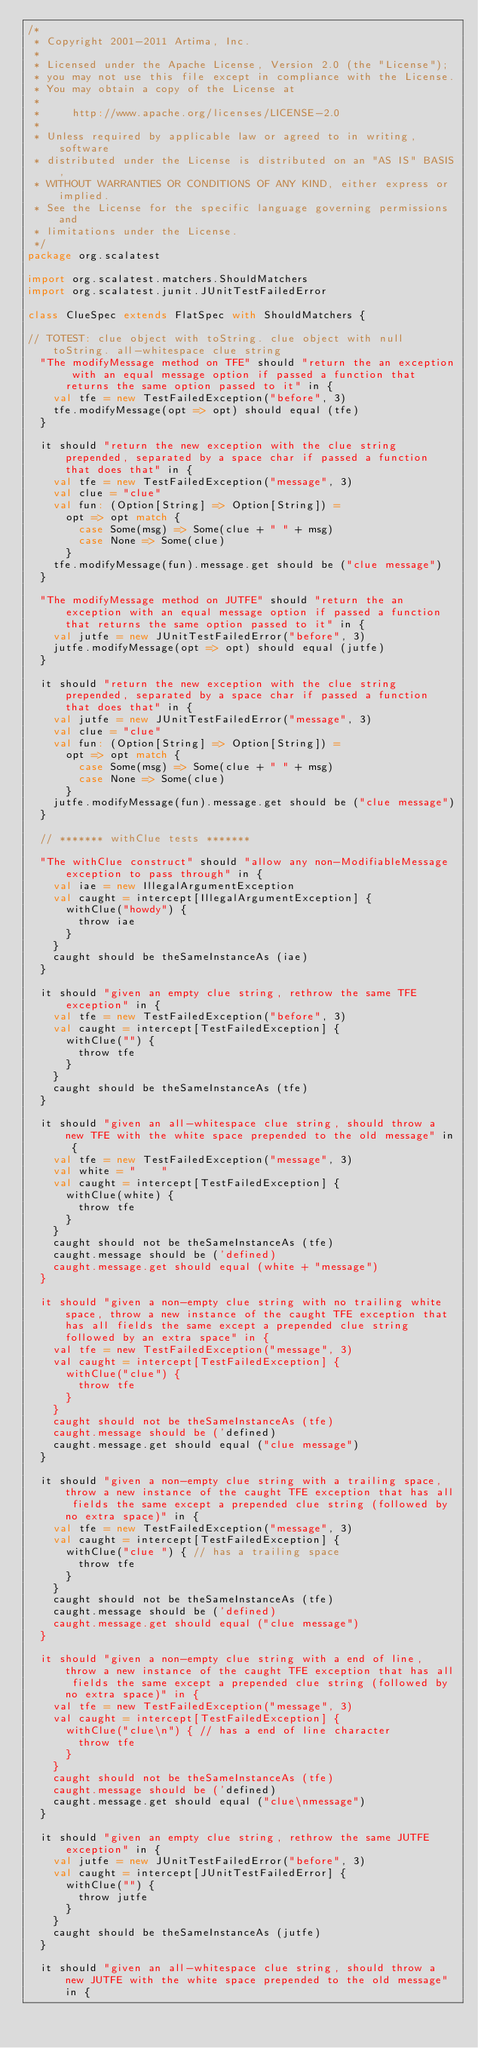<code> <loc_0><loc_0><loc_500><loc_500><_Scala_>/*
 * Copyright 2001-2011 Artima, Inc.
 *
 * Licensed under the Apache License, Version 2.0 (the "License");
 * you may not use this file except in compliance with the License.
 * You may obtain a copy of the License at
 *
 *     http://www.apache.org/licenses/LICENSE-2.0
 *
 * Unless required by applicable law or agreed to in writing, software
 * distributed under the License is distributed on an "AS IS" BASIS,
 * WITHOUT WARRANTIES OR CONDITIONS OF ANY KIND, either express or implied.
 * See the License for the specific language governing permissions and
 * limitations under the License.
 */
package org.scalatest

import org.scalatest.matchers.ShouldMatchers
import org.scalatest.junit.JUnitTestFailedError

class ClueSpec extends FlatSpec with ShouldMatchers {

// TOTEST: clue object with toString. clue object with null toString. all-whitespace clue string
  "The modifyMessage method on TFE" should "return the an exception with an equal message option if passed a function that returns the same option passed to it" in {
    val tfe = new TestFailedException("before", 3)
    tfe.modifyMessage(opt => opt) should equal (tfe)
  }

  it should "return the new exception with the clue string prepended, separated by a space char if passed a function that does that" in {
    val tfe = new TestFailedException("message", 3)
    val clue = "clue"
    val fun: (Option[String] => Option[String]) =
      opt => opt match {
        case Some(msg) => Some(clue + " " + msg)
        case None => Some(clue)
      }
    tfe.modifyMessage(fun).message.get should be ("clue message")
  }

  "The modifyMessage method on JUTFE" should "return the an exception with an equal message option if passed a function that returns the same option passed to it" in {
    val jutfe = new JUnitTestFailedError("before", 3)
    jutfe.modifyMessage(opt => opt) should equal (jutfe)
  }

  it should "return the new exception with the clue string prepended, separated by a space char if passed a function that does that" in {
    val jutfe = new JUnitTestFailedError("message", 3)
    val clue = "clue"
    val fun: (Option[String] => Option[String]) =
      opt => opt match {
        case Some(msg) => Some(clue + " " + msg)
        case None => Some(clue)
      }
    jutfe.modifyMessage(fun).message.get should be ("clue message")
  }

  // ******* withClue tests *******

  "The withClue construct" should "allow any non-ModifiableMessage exception to pass through" in {
    val iae = new IllegalArgumentException
    val caught = intercept[IllegalArgumentException] {
      withClue("howdy") {
        throw iae 
      }
    }
    caught should be theSameInstanceAs (iae)
  }

  it should "given an empty clue string, rethrow the same TFE exception" in {
    val tfe = new TestFailedException("before", 3)
    val caught = intercept[TestFailedException] {
      withClue("") {
        throw tfe 
      }
    }
    caught should be theSameInstanceAs (tfe)
  }

  it should "given an all-whitespace clue string, should throw a new TFE with the white space prepended to the old message" in {
    val tfe = new TestFailedException("message", 3)
    val white = "    "
    val caught = intercept[TestFailedException] {
      withClue(white) {
        throw tfe 
      }
    }
    caught should not be theSameInstanceAs (tfe)
    caught.message should be ('defined)
    caught.message.get should equal (white + "message")
  }

  it should "given a non-empty clue string with no trailing white space, throw a new instance of the caught TFE exception that has all fields the same except a prepended clue string followed by an extra space" in {
    val tfe = new TestFailedException("message", 3)
    val caught = intercept[TestFailedException] {
      withClue("clue") {
        throw tfe 
      }
    }
    caught should not be theSameInstanceAs (tfe)
    caught.message should be ('defined)
    caught.message.get should equal ("clue message")
  }

  it should "given a non-empty clue string with a trailing space, throw a new instance of the caught TFE exception that has all fields the same except a prepended clue string (followed by no extra space)" in {
    val tfe = new TestFailedException("message", 3)
    val caught = intercept[TestFailedException] {
      withClue("clue ") { // has a trailing space
        throw tfe 
      }
    }
    caught should not be theSameInstanceAs (tfe)
    caught.message should be ('defined)
    caught.message.get should equal ("clue message")
  }

  it should "given a non-empty clue string with a end of line, throw a new instance of the caught TFE exception that has all fields the same except a prepended clue string (followed by no extra space)" in {
    val tfe = new TestFailedException("message", 3)
    val caught = intercept[TestFailedException] {
      withClue("clue\n") { // has a end of line character
        throw tfe 
      }
    }
    caught should not be theSameInstanceAs (tfe)
    caught.message should be ('defined)
    caught.message.get should equal ("clue\nmessage")
  }

  it should "given an empty clue string, rethrow the same JUTFE exception" in {
    val jutfe = new JUnitTestFailedError("before", 3)
    val caught = intercept[JUnitTestFailedError] {
      withClue("") {
        throw jutfe 
      }
    }
    caught should be theSameInstanceAs (jutfe)
  }

  it should "given an all-whitespace clue string, should throw a new JUTFE with the white space prepended to the old message" in {</code> 